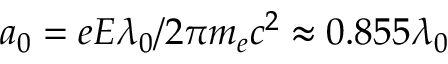<formula> <loc_0><loc_0><loc_500><loc_500>a _ { 0 } = e E \lambda _ { 0 } / 2 \pi m _ { e } c ^ { 2 } \approx 0 . 8 5 5 \lambda _ { 0 }</formula> 